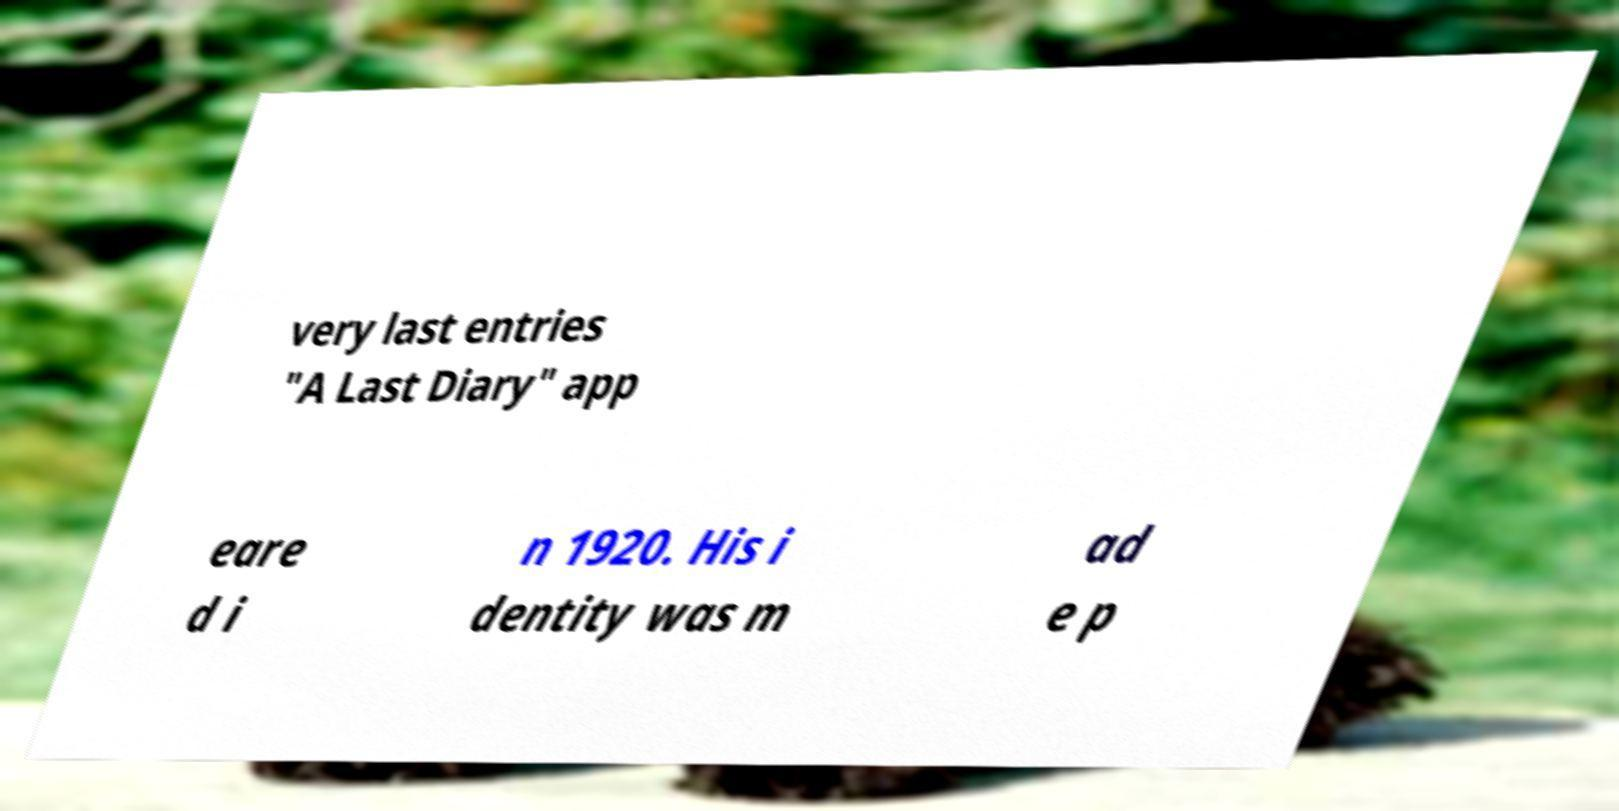There's text embedded in this image that I need extracted. Can you transcribe it verbatim? very last entries "A Last Diary" app eare d i n 1920. His i dentity was m ad e p 